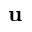Convert formula to latex. <formula><loc_0><loc_0><loc_500><loc_500>u</formula> 